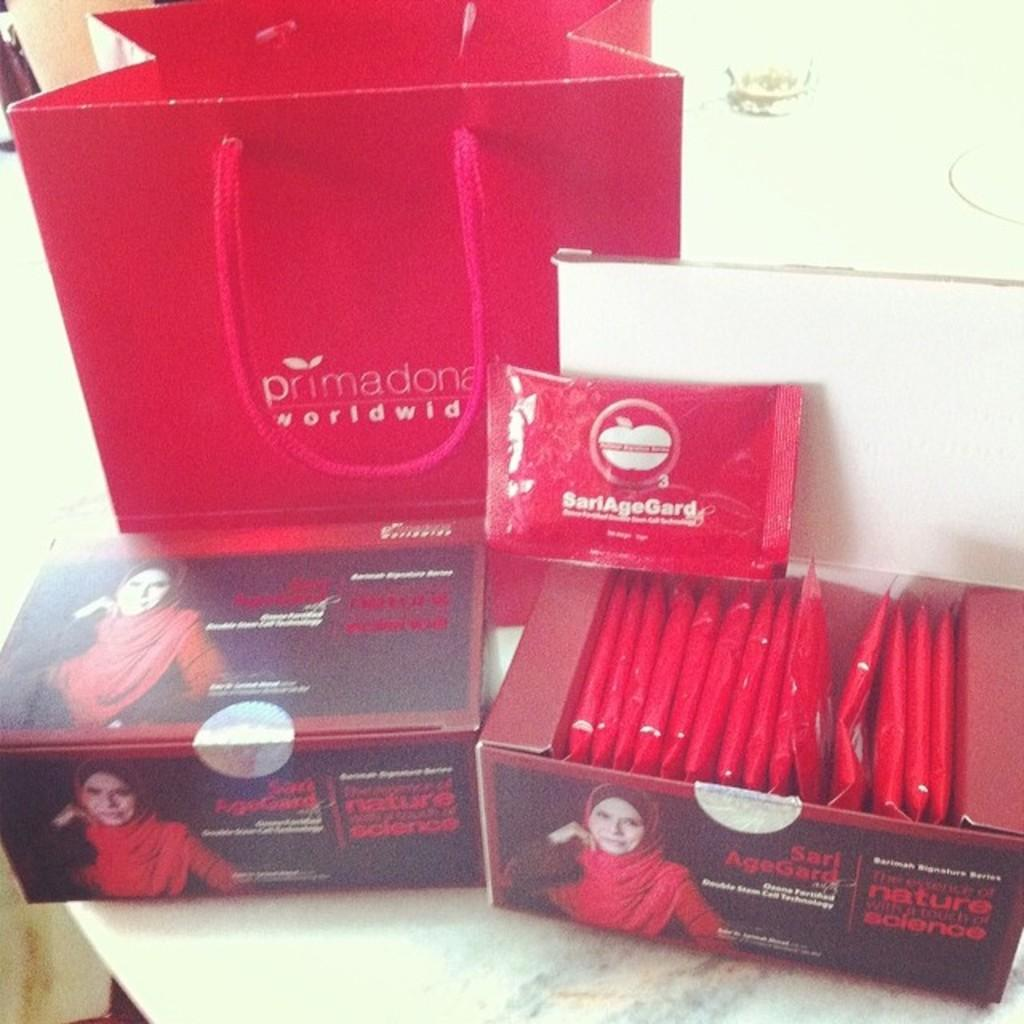How many boxes are visible in the image? There are two boxes in the image. What other items can be seen in the image besides the boxes? There is a bag and packets in the image. What is the color of the packets? The packets are pink in color. Where are the boxes, bag, and packets located in the image? The items are placed on a table. What disease is being treated with the packets in the image? There is no indication of any disease or medical treatment in the image; it simply shows boxes, a bag, and pink packets on a table. 